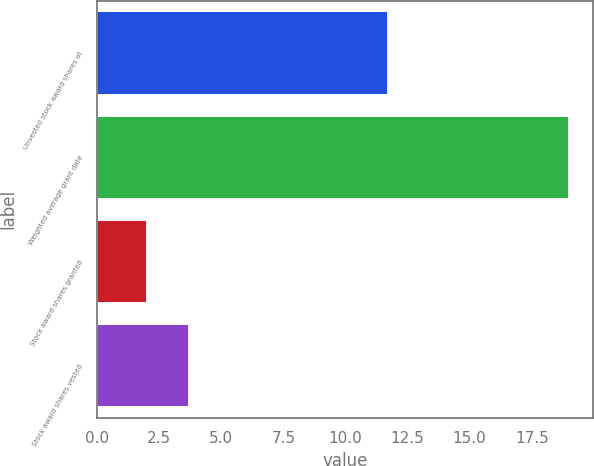Convert chart to OTSL. <chart><loc_0><loc_0><loc_500><loc_500><bar_chart><fcel>Unvested stock award shares at<fcel>Weighted average grant date<fcel>Stock award shares granted<fcel>Stock award shares vested<nl><fcel>11.7<fcel>19<fcel>2<fcel>3.7<nl></chart> 